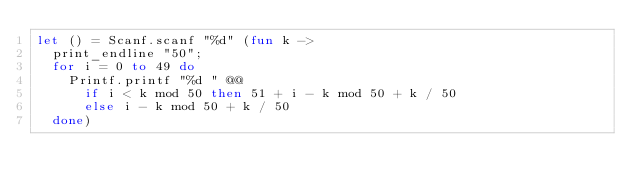Convert code to text. <code><loc_0><loc_0><loc_500><loc_500><_OCaml_>let () = Scanf.scanf "%d" (fun k ->
  print_endline "50";
  for i = 0 to 49 do
    Printf.printf "%d " @@
      if i < k mod 50 then 51 + i - k mod 50 + k / 50
      else i - k mod 50 + k / 50
  done)</code> 